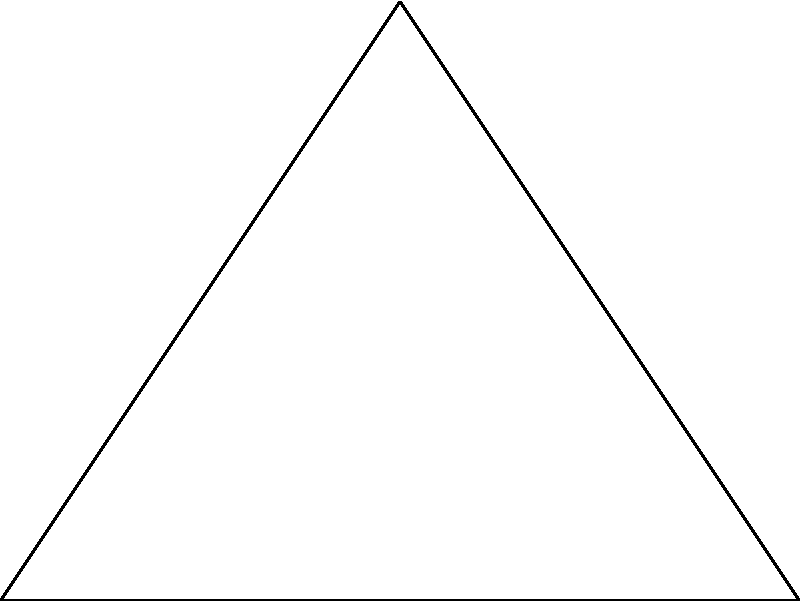As an escrow officer, you need to determine the distance between two properties (A and B) using triangulation methods. A surveyor has provided you with the following information: from a third point C, the distance to property A is 4 km, and the distance to property B is 6 km. The angle ACB is a right angle. Calculate the distance between properties A and B. To solve this problem, we can use the Pythagorean theorem, as we have a right-angled triangle.

Step 1: Identify the known variables
- AC = 4 km (distance from C to A)
- BC = 6 km (distance from C to B)
- Angle ACB = 90° (right angle)

Step 2: Apply the Pythagorean theorem
The Pythagorean theorem states that in a right-angled triangle, the square of the hypotenuse (the side opposite the right angle) is equal to the sum of squares of the other two sides.

Let x be the distance between A and B. Then:

$$ x^2 = AC^2 + BC^2 $$

Step 3: Substitute the known values
$$ x^2 = 4^2 + 6^2 $$

Step 4: Calculate
$$ x^2 = 16 + 36 = 52 $$

Step 5: Solve for x by taking the square root of both sides
$$ x = \sqrt{52} $$

Step 6: Simplify the square root
$$ x = 2\sqrt{13} \approx 7.21 \text{ km} $$

Therefore, the distance between properties A and B is $2\sqrt{13}$ km or approximately 7.21 km.
Answer: $2\sqrt{13}$ km 